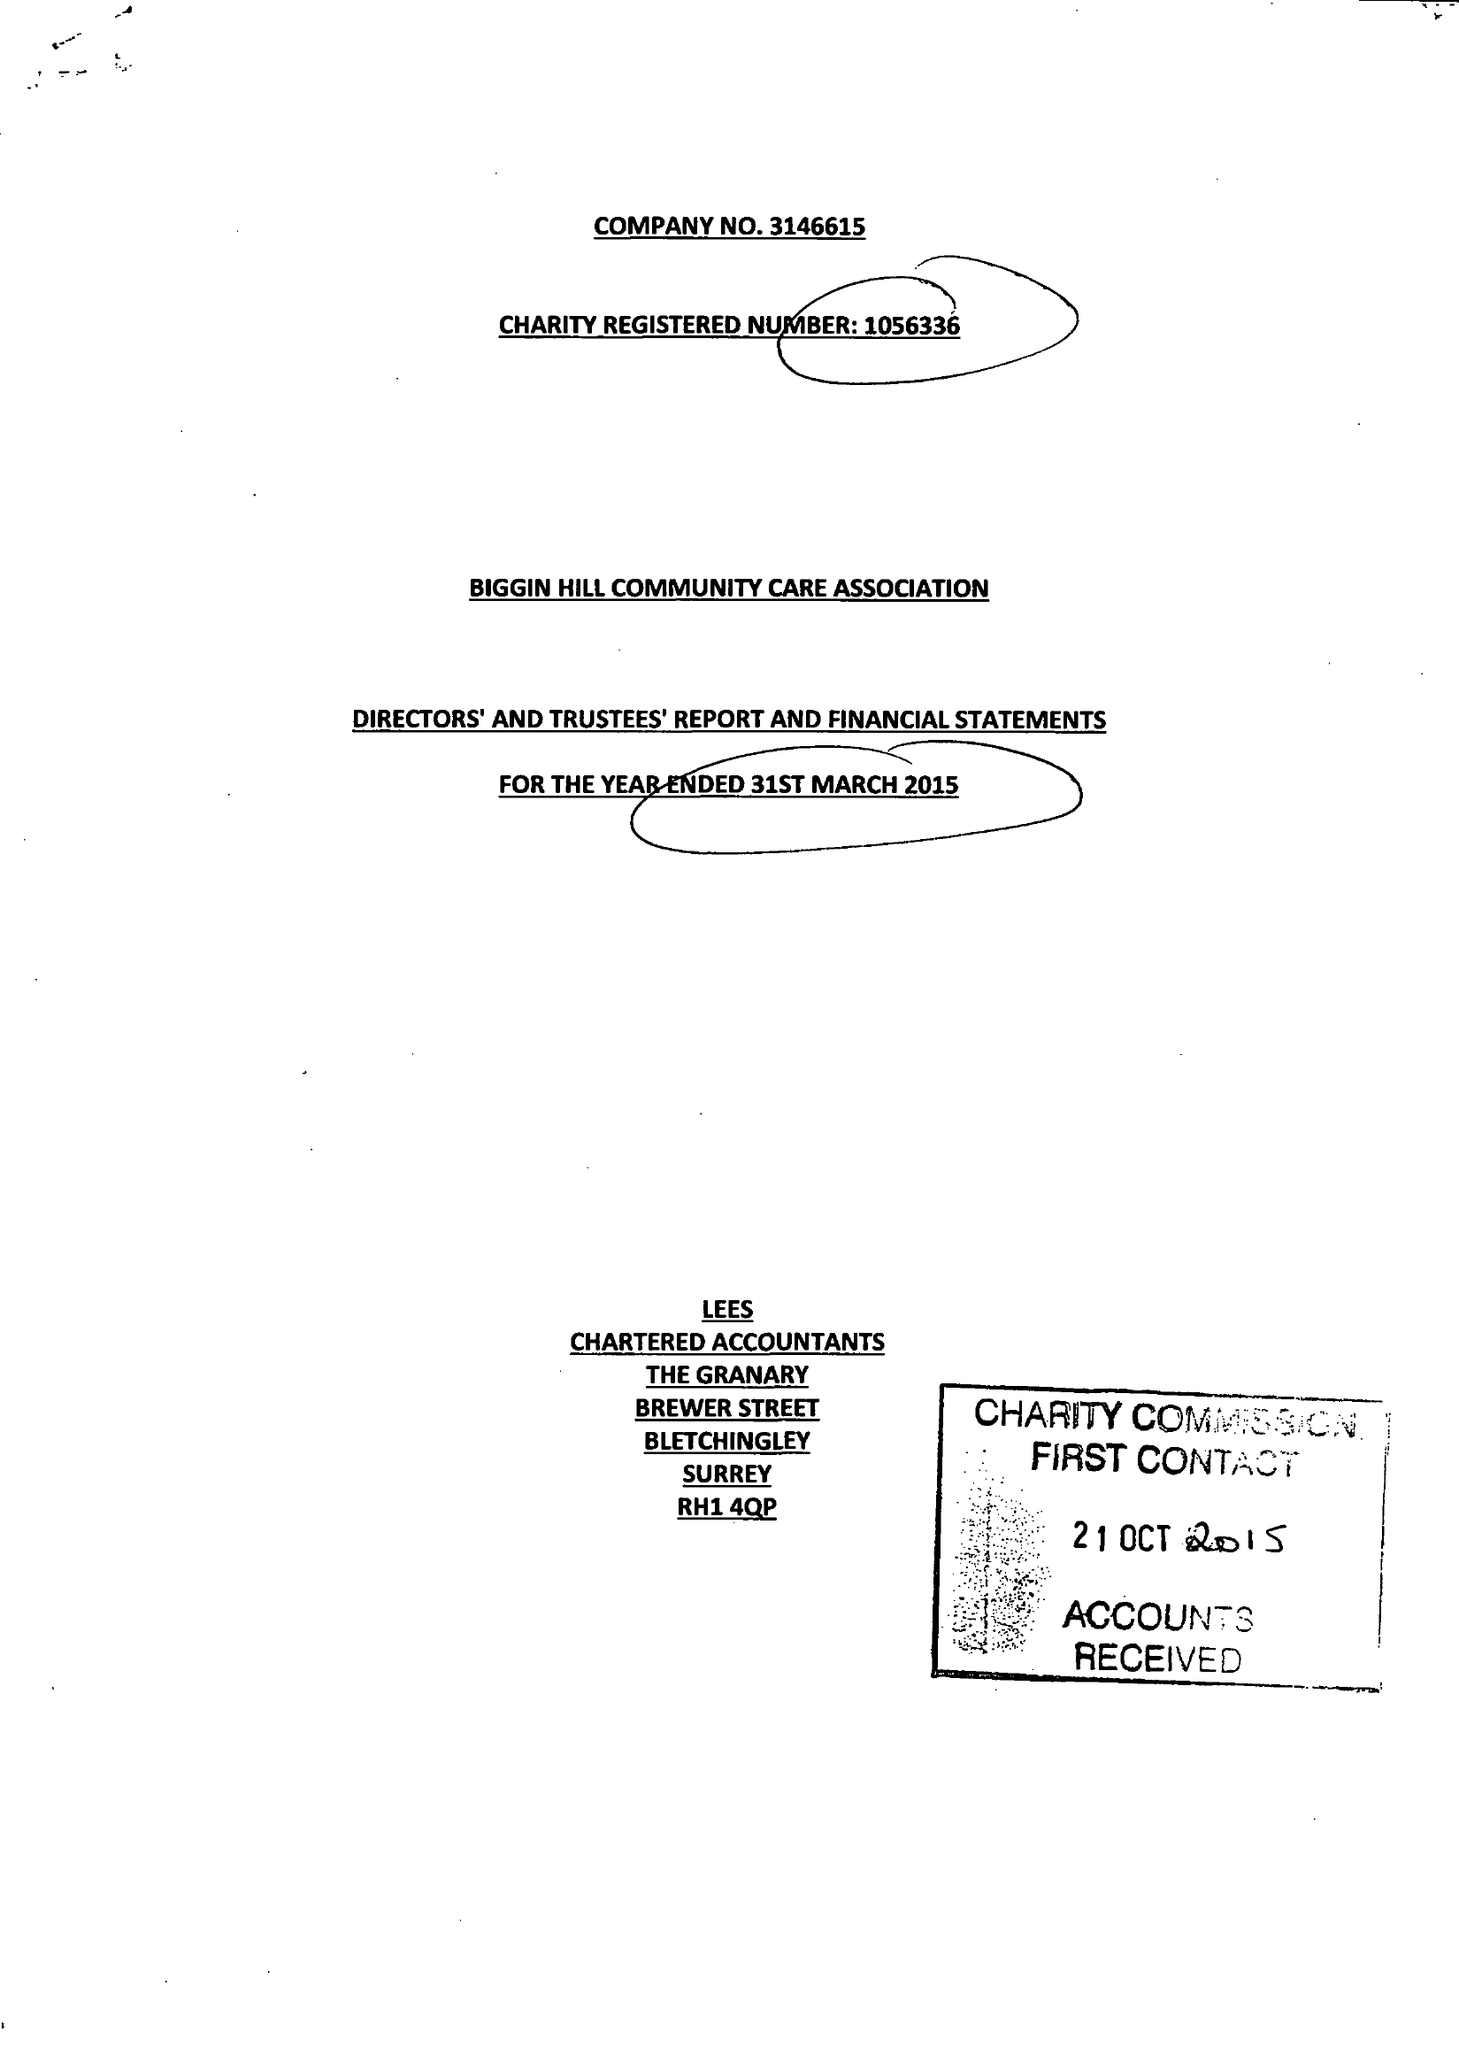What is the value for the report_date?
Answer the question using a single word or phrase. 2015-03-31 